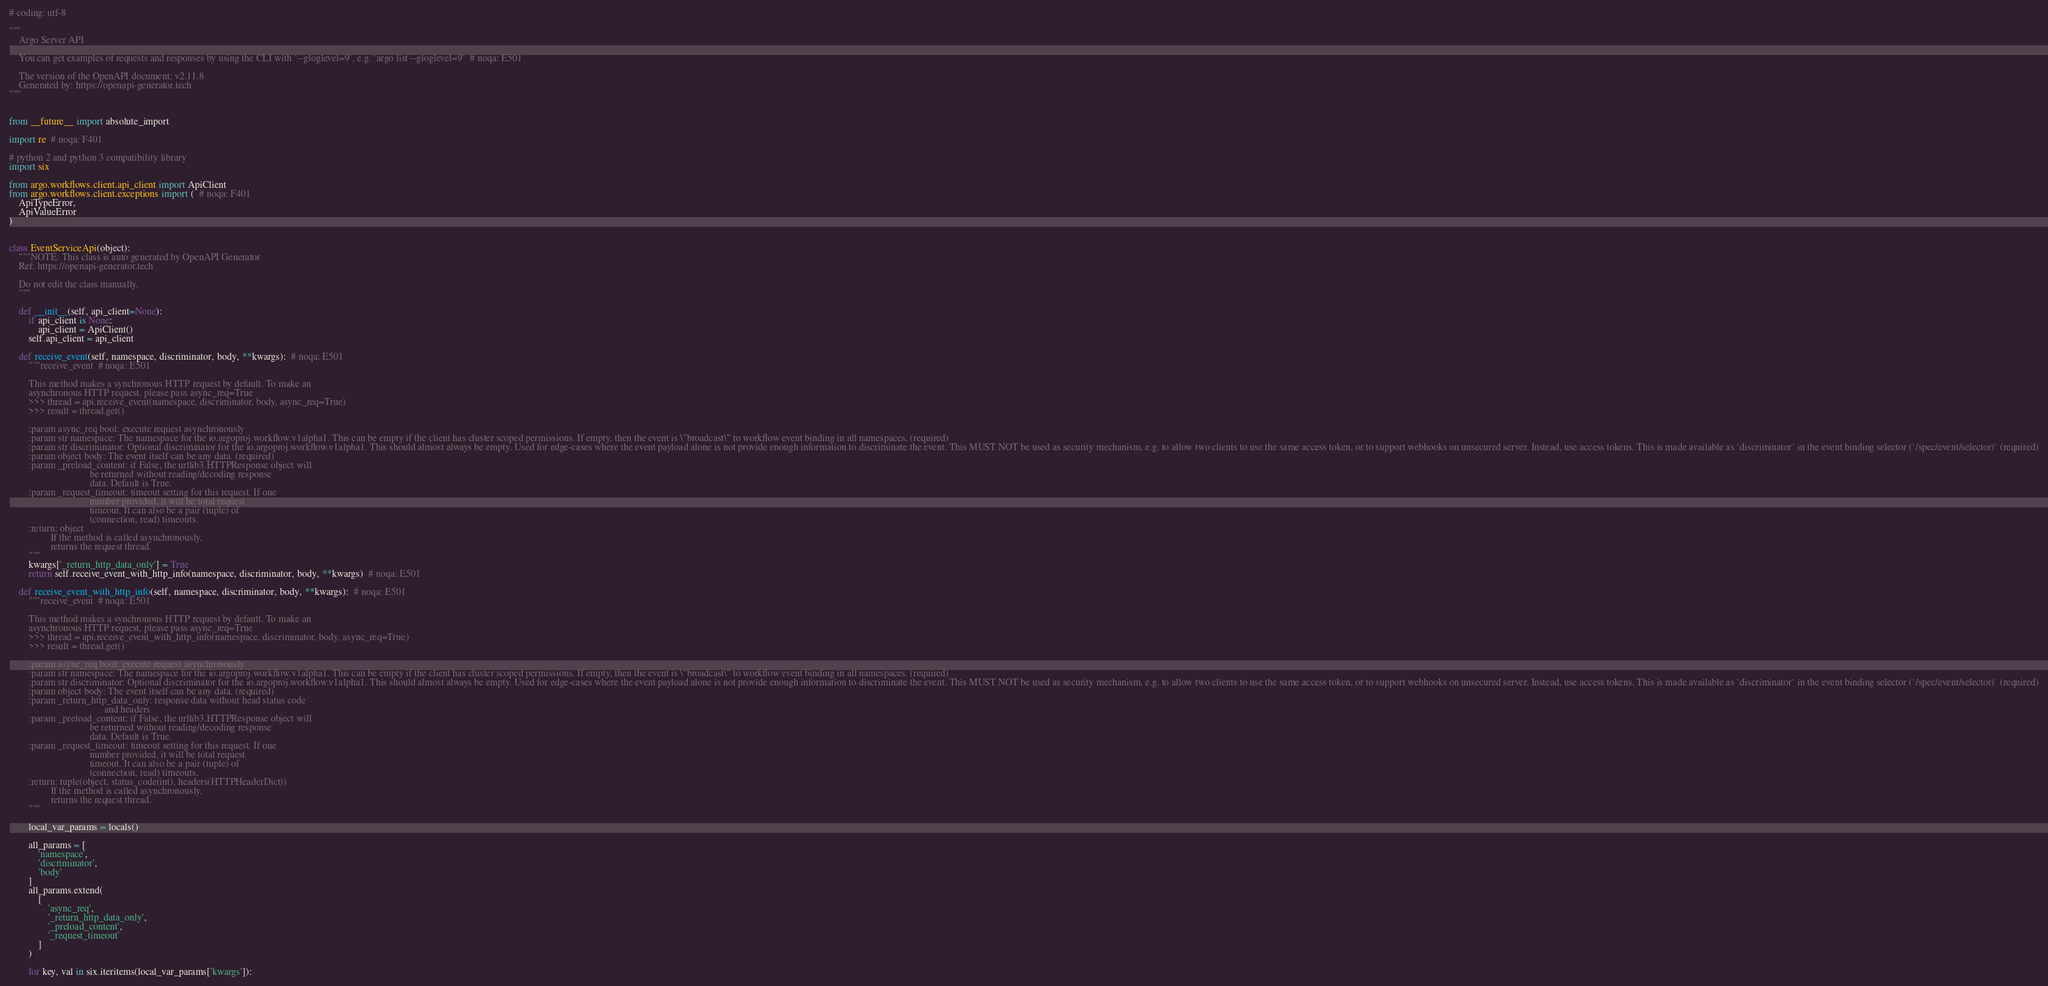Convert code to text. <code><loc_0><loc_0><loc_500><loc_500><_Python_># coding: utf-8

"""
    Argo Server API

    You can get examples of requests and responses by using the CLI with `--gloglevel=9`, e.g. `argo list --gloglevel=9`  # noqa: E501

    The version of the OpenAPI document: v2.11.8
    Generated by: https://openapi-generator.tech
"""


from __future__ import absolute_import

import re  # noqa: F401

# python 2 and python 3 compatibility library
import six

from argo.workflows.client.api_client import ApiClient
from argo.workflows.client.exceptions import (  # noqa: F401
    ApiTypeError,
    ApiValueError
)


class EventServiceApi(object):
    """NOTE: This class is auto generated by OpenAPI Generator
    Ref: https://openapi-generator.tech

    Do not edit the class manually.
    """

    def __init__(self, api_client=None):
        if api_client is None:
            api_client = ApiClient()
        self.api_client = api_client

    def receive_event(self, namespace, discriminator, body, **kwargs):  # noqa: E501
        """receive_event  # noqa: E501

        This method makes a synchronous HTTP request by default. To make an
        asynchronous HTTP request, please pass async_req=True
        >>> thread = api.receive_event(namespace, discriminator, body, async_req=True)
        >>> result = thread.get()

        :param async_req bool: execute request asynchronously
        :param str namespace: The namespace for the io.argoproj.workflow.v1alpha1. This can be empty if the client has cluster scoped permissions. If empty, then the event is \"broadcast\" to workflow event binding in all namespaces. (required)
        :param str discriminator: Optional discriminator for the io.argoproj.workflow.v1alpha1. This should almost always be empty. Used for edge-cases where the event payload alone is not provide enough information to discriminate the event. This MUST NOT be used as security mechanism, e.g. to allow two clients to use the same access token, or to support webhooks on unsecured server. Instead, use access tokens. This is made available as `discriminator` in the event binding selector (`/spec/event/selector)` (required)
        :param object body: The event itself can be any data. (required)
        :param _preload_content: if False, the urllib3.HTTPResponse object will
                                 be returned without reading/decoding response
                                 data. Default is True.
        :param _request_timeout: timeout setting for this request. If one
                                 number provided, it will be total request
                                 timeout. It can also be a pair (tuple) of
                                 (connection, read) timeouts.
        :return: object
                 If the method is called asynchronously,
                 returns the request thread.
        """
        kwargs['_return_http_data_only'] = True
        return self.receive_event_with_http_info(namespace, discriminator, body, **kwargs)  # noqa: E501

    def receive_event_with_http_info(self, namespace, discriminator, body, **kwargs):  # noqa: E501
        """receive_event  # noqa: E501

        This method makes a synchronous HTTP request by default. To make an
        asynchronous HTTP request, please pass async_req=True
        >>> thread = api.receive_event_with_http_info(namespace, discriminator, body, async_req=True)
        >>> result = thread.get()

        :param async_req bool: execute request asynchronously
        :param str namespace: The namespace for the io.argoproj.workflow.v1alpha1. This can be empty if the client has cluster scoped permissions. If empty, then the event is \"broadcast\" to workflow event binding in all namespaces. (required)
        :param str discriminator: Optional discriminator for the io.argoproj.workflow.v1alpha1. This should almost always be empty. Used for edge-cases where the event payload alone is not provide enough information to discriminate the event. This MUST NOT be used as security mechanism, e.g. to allow two clients to use the same access token, or to support webhooks on unsecured server. Instead, use access tokens. This is made available as `discriminator` in the event binding selector (`/spec/event/selector)` (required)
        :param object body: The event itself can be any data. (required)
        :param _return_http_data_only: response data without head status code
                                       and headers
        :param _preload_content: if False, the urllib3.HTTPResponse object will
                                 be returned without reading/decoding response
                                 data. Default is True.
        :param _request_timeout: timeout setting for this request. If one
                                 number provided, it will be total request
                                 timeout. It can also be a pair (tuple) of
                                 (connection, read) timeouts.
        :return: tuple(object, status_code(int), headers(HTTPHeaderDict))
                 If the method is called asynchronously,
                 returns the request thread.
        """

        local_var_params = locals()

        all_params = [
            'namespace',
            'discriminator',
            'body'
        ]
        all_params.extend(
            [
                'async_req',
                '_return_http_data_only',
                '_preload_content',
                '_request_timeout'
            ]
        )

        for key, val in six.iteritems(local_var_params['kwargs']):</code> 